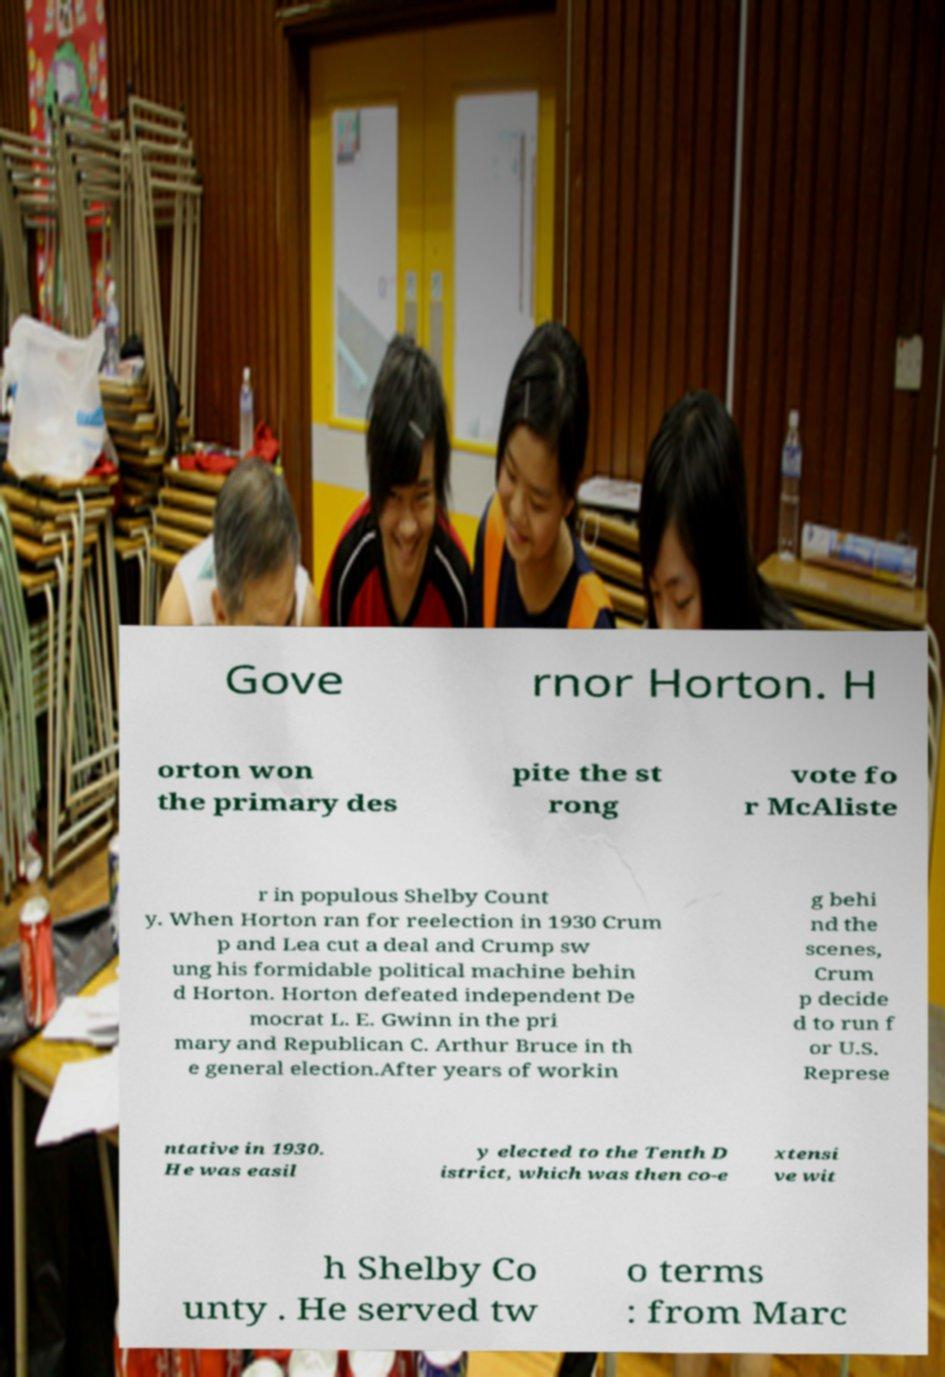Please identify and transcribe the text found in this image. Gove rnor Horton. H orton won the primary des pite the st rong vote fo r McAliste r in populous Shelby Count y. When Horton ran for reelection in 1930 Crum p and Lea cut a deal and Crump sw ung his formidable political machine behin d Horton. Horton defeated independent De mocrat L. E. Gwinn in the pri mary and Republican C. Arthur Bruce in th e general election.After years of workin g behi nd the scenes, Crum p decide d to run f or U.S. Represe ntative in 1930. He was easil y elected to the Tenth D istrict, which was then co-e xtensi ve wit h Shelby Co unty . He served tw o terms : from Marc 